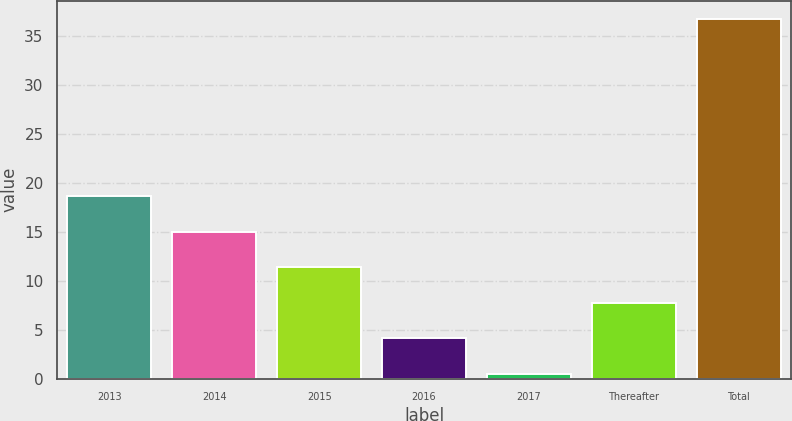<chart> <loc_0><loc_0><loc_500><loc_500><bar_chart><fcel>2013<fcel>2014<fcel>2015<fcel>2016<fcel>2017<fcel>Thereafter<fcel>Total<nl><fcel>18.65<fcel>15.02<fcel>11.39<fcel>4.13<fcel>0.5<fcel>7.76<fcel>36.8<nl></chart> 